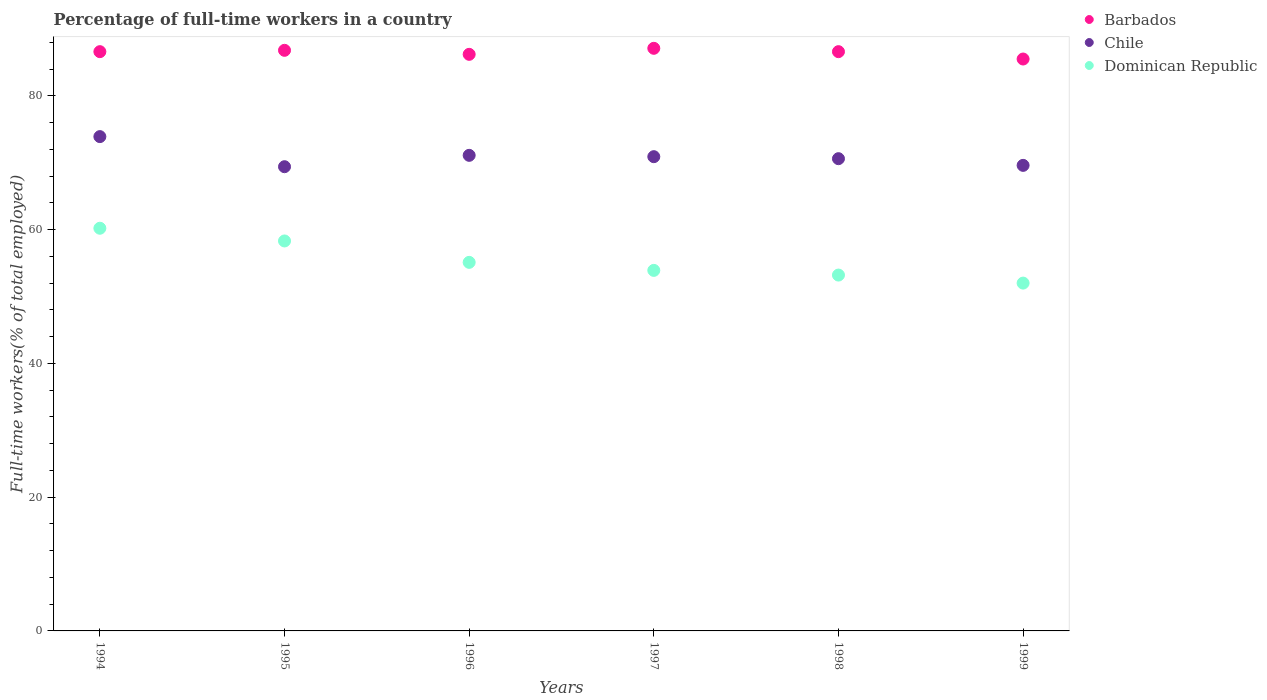Is the number of dotlines equal to the number of legend labels?
Give a very brief answer. Yes. What is the percentage of full-time workers in Barbados in 1995?
Your answer should be very brief. 86.8. Across all years, what is the maximum percentage of full-time workers in Chile?
Give a very brief answer. 73.9. Across all years, what is the minimum percentage of full-time workers in Dominican Republic?
Ensure brevity in your answer.  52. What is the total percentage of full-time workers in Dominican Republic in the graph?
Provide a succinct answer. 332.7. What is the difference between the percentage of full-time workers in Barbados in 1996 and that in 1998?
Your response must be concise. -0.4. What is the difference between the percentage of full-time workers in Barbados in 1998 and the percentage of full-time workers in Dominican Republic in 1996?
Your response must be concise. 31.5. What is the average percentage of full-time workers in Barbados per year?
Your answer should be compact. 86.47. In the year 1996, what is the difference between the percentage of full-time workers in Dominican Republic and percentage of full-time workers in Barbados?
Keep it short and to the point. -31.1. What is the ratio of the percentage of full-time workers in Dominican Republic in 1995 to that in 1998?
Your response must be concise. 1.1. What is the difference between the highest and the second highest percentage of full-time workers in Chile?
Ensure brevity in your answer.  2.8. What is the difference between the highest and the lowest percentage of full-time workers in Dominican Republic?
Keep it short and to the point. 8.2. Is the sum of the percentage of full-time workers in Chile in 1995 and 1997 greater than the maximum percentage of full-time workers in Barbados across all years?
Your response must be concise. Yes. Is it the case that in every year, the sum of the percentage of full-time workers in Dominican Republic and percentage of full-time workers in Chile  is greater than the percentage of full-time workers in Barbados?
Offer a terse response. Yes. Is the percentage of full-time workers in Chile strictly less than the percentage of full-time workers in Barbados over the years?
Provide a short and direct response. Yes. How many dotlines are there?
Ensure brevity in your answer.  3. How many years are there in the graph?
Give a very brief answer. 6. What is the difference between two consecutive major ticks on the Y-axis?
Your answer should be very brief. 20. Does the graph contain grids?
Provide a succinct answer. No. What is the title of the graph?
Your response must be concise. Percentage of full-time workers in a country. What is the label or title of the Y-axis?
Offer a terse response. Full-time workers(% of total employed). What is the Full-time workers(% of total employed) in Barbados in 1994?
Offer a terse response. 86.6. What is the Full-time workers(% of total employed) in Chile in 1994?
Your response must be concise. 73.9. What is the Full-time workers(% of total employed) in Dominican Republic in 1994?
Provide a succinct answer. 60.2. What is the Full-time workers(% of total employed) of Barbados in 1995?
Your answer should be compact. 86.8. What is the Full-time workers(% of total employed) of Chile in 1995?
Provide a succinct answer. 69.4. What is the Full-time workers(% of total employed) in Dominican Republic in 1995?
Your response must be concise. 58.3. What is the Full-time workers(% of total employed) in Barbados in 1996?
Provide a succinct answer. 86.2. What is the Full-time workers(% of total employed) of Chile in 1996?
Your answer should be compact. 71.1. What is the Full-time workers(% of total employed) of Dominican Republic in 1996?
Ensure brevity in your answer.  55.1. What is the Full-time workers(% of total employed) in Barbados in 1997?
Provide a succinct answer. 87.1. What is the Full-time workers(% of total employed) in Chile in 1997?
Offer a terse response. 70.9. What is the Full-time workers(% of total employed) in Dominican Republic in 1997?
Provide a short and direct response. 53.9. What is the Full-time workers(% of total employed) in Barbados in 1998?
Your response must be concise. 86.6. What is the Full-time workers(% of total employed) of Chile in 1998?
Make the answer very short. 70.6. What is the Full-time workers(% of total employed) in Dominican Republic in 1998?
Offer a very short reply. 53.2. What is the Full-time workers(% of total employed) in Barbados in 1999?
Provide a short and direct response. 85.5. What is the Full-time workers(% of total employed) in Chile in 1999?
Provide a short and direct response. 69.6. Across all years, what is the maximum Full-time workers(% of total employed) of Barbados?
Offer a terse response. 87.1. Across all years, what is the maximum Full-time workers(% of total employed) of Chile?
Your answer should be compact. 73.9. Across all years, what is the maximum Full-time workers(% of total employed) in Dominican Republic?
Offer a terse response. 60.2. Across all years, what is the minimum Full-time workers(% of total employed) in Barbados?
Ensure brevity in your answer.  85.5. Across all years, what is the minimum Full-time workers(% of total employed) of Chile?
Make the answer very short. 69.4. Across all years, what is the minimum Full-time workers(% of total employed) of Dominican Republic?
Your answer should be very brief. 52. What is the total Full-time workers(% of total employed) in Barbados in the graph?
Provide a short and direct response. 518.8. What is the total Full-time workers(% of total employed) of Chile in the graph?
Offer a very short reply. 425.5. What is the total Full-time workers(% of total employed) in Dominican Republic in the graph?
Make the answer very short. 332.7. What is the difference between the Full-time workers(% of total employed) of Barbados in 1994 and that in 1995?
Keep it short and to the point. -0.2. What is the difference between the Full-time workers(% of total employed) of Chile in 1994 and that in 1995?
Your response must be concise. 4.5. What is the difference between the Full-time workers(% of total employed) of Dominican Republic in 1994 and that in 1996?
Offer a terse response. 5.1. What is the difference between the Full-time workers(% of total employed) of Dominican Republic in 1994 and that in 1997?
Your response must be concise. 6.3. What is the difference between the Full-time workers(% of total employed) of Chile in 1994 and that in 1998?
Ensure brevity in your answer.  3.3. What is the difference between the Full-time workers(% of total employed) in Dominican Republic in 1994 and that in 1998?
Give a very brief answer. 7. What is the difference between the Full-time workers(% of total employed) of Dominican Republic in 1995 and that in 1996?
Make the answer very short. 3.2. What is the difference between the Full-time workers(% of total employed) of Chile in 1995 and that in 1997?
Ensure brevity in your answer.  -1.5. What is the difference between the Full-time workers(% of total employed) in Dominican Republic in 1995 and that in 1997?
Offer a very short reply. 4.4. What is the difference between the Full-time workers(% of total employed) of Chile in 1995 and that in 1998?
Make the answer very short. -1.2. What is the difference between the Full-time workers(% of total employed) in Dominican Republic in 1995 and that in 1998?
Provide a succinct answer. 5.1. What is the difference between the Full-time workers(% of total employed) in Chile in 1996 and that in 1997?
Your answer should be compact. 0.2. What is the difference between the Full-time workers(% of total employed) of Barbados in 1996 and that in 1998?
Offer a very short reply. -0.4. What is the difference between the Full-time workers(% of total employed) of Chile in 1996 and that in 1998?
Ensure brevity in your answer.  0.5. What is the difference between the Full-time workers(% of total employed) of Barbados in 1996 and that in 1999?
Ensure brevity in your answer.  0.7. What is the difference between the Full-time workers(% of total employed) in Chile in 1997 and that in 1998?
Keep it short and to the point. 0.3. What is the difference between the Full-time workers(% of total employed) in Dominican Republic in 1997 and that in 1998?
Offer a terse response. 0.7. What is the difference between the Full-time workers(% of total employed) of Chile in 1997 and that in 1999?
Offer a terse response. 1.3. What is the difference between the Full-time workers(% of total employed) of Chile in 1998 and that in 1999?
Offer a very short reply. 1. What is the difference between the Full-time workers(% of total employed) in Barbados in 1994 and the Full-time workers(% of total employed) in Chile in 1995?
Your answer should be very brief. 17.2. What is the difference between the Full-time workers(% of total employed) in Barbados in 1994 and the Full-time workers(% of total employed) in Dominican Republic in 1995?
Your answer should be very brief. 28.3. What is the difference between the Full-time workers(% of total employed) in Chile in 1994 and the Full-time workers(% of total employed) in Dominican Republic in 1995?
Ensure brevity in your answer.  15.6. What is the difference between the Full-time workers(% of total employed) in Barbados in 1994 and the Full-time workers(% of total employed) in Dominican Republic in 1996?
Give a very brief answer. 31.5. What is the difference between the Full-time workers(% of total employed) in Barbados in 1994 and the Full-time workers(% of total employed) in Dominican Republic in 1997?
Make the answer very short. 32.7. What is the difference between the Full-time workers(% of total employed) in Chile in 1994 and the Full-time workers(% of total employed) in Dominican Republic in 1997?
Provide a succinct answer. 20. What is the difference between the Full-time workers(% of total employed) of Barbados in 1994 and the Full-time workers(% of total employed) of Dominican Republic in 1998?
Offer a terse response. 33.4. What is the difference between the Full-time workers(% of total employed) in Chile in 1994 and the Full-time workers(% of total employed) in Dominican Republic in 1998?
Your response must be concise. 20.7. What is the difference between the Full-time workers(% of total employed) of Barbados in 1994 and the Full-time workers(% of total employed) of Chile in 1999?
Offer a very short reply. 17. What is the difference between the Full-time workers(% of total employed) of Barbados in 1994 and the Full-time workers(% of total employed) of Dominican Republic in 1999?
Offer a very short reply. 34.6. What is the difference between the Full-time workers(% of total employed) in Chile in 1994 and the Full-time workers(% of total employed) in Dominican Republic in 1999?
Keep it short and to the point. 21.9. What is the difference between the Full-time workers(% of total employed) in Barbados in 1995 and the Full-time workers(% of total employed) in Chile in 1996?
Your answer should be very brief. 15.7. What is the difference between the Full-time workers(% of total employed) in Barbados in 1995 and the Full-time workers(% of total employed) in Dominican Republic in 1996?
Your answer should be very brief. 31.7. What is the difference between the Full-time workers(% of total employed) of Chile in 1995 and the Full-time workers(% of total employed) of Dominican Republic in 1996?
Provide a succinct answer. 14.3. What is the difference between the Full-time workers(% of total employed) of Barbados in 1995 and the Full-time workers(% of total employed) of Dominican Republic in 1997?
Give a very brief answer. 32.9. What is the difference between the Full-time workers(% of total employed) in Barbados in 1995 and the Full-time workers(% of total employed) in Chile in 1998?
Keep it short and to the point. 16.2. What is the difference between the Full-time workers(% of total employed) in Barbados in 1995 and the Full-time workers(% of total employed) in Dominican Republic in 1998?
Offer a very short reply. 33.6. What is the difference between the Full-time workers(% of total employed) of Chile in 1995 and the Full-time workers(% of total employed) of Dominican Republic in 1998?
Your answer should be very brief. 16.2. What is the difference between the Full-time workers(% of total employed) of Barbados in 1995 and the Full-time workers(% of total employed) of Chile in 1999?
Your answer should be compact. 17.2. What is the difference between the Full-time workers(% of total employed) in Barbados in 1995 and the Full-time workers(% of total employed) in Dominican Republic in 1999?
Keep it short and to the point. 34.8. What is the difference between the Full-time workers(% of total employed) of Chile in 1995 and the Full-time workers(% of total employed) of Dominican Republic in 1999?
Your response must be concise. 17.4. What is the difference between the Full-time workers(% of total employed) in Barbados in 1996 and the Full-time workers(% of total employed) in Chile in 1997?
Keep it short and to the point. 15.3. What is the difference between the Full-time workers(% of total employed) of Barbados in 1996 and the Full-time workers(% of total employed) of Dominican Republic in 1997?
Your response must be concise. 32.3. What is the difference between the Full-time workers(% of total employed) of Barbados in 1996 and the Full-time workers(% of total employed) of Chile in 1998?
Offer a terse response. 15.6. What is the difference between the Full-time workers(% of total employed) of Barbados in 1996 and the Full-time workers(% of total employed) of Dominican Republic in 1998?
Offer a very short reply. 33. What is the difference between the Full-time workers(% of total employed) in Chile in 1996 and the Full-time workers(% of total employed) in Dominican Republic in 1998?
Provide a short and direct response. 17.9. What is the difference between the Full-time workers(% of total employed) in Barbados in 1996 and the Full-time workers(% of total employed) in Chile in 1999?
Your answer should be very brief. 16.6. What is the difference between the Full-time workers(% of total employed) of Barbados in 1996 and the Full-time workers(% of total employed) of Dominican Republic in 1999?
Your response must be concise. 34.2. What is the difference between the Full-time workers(% of total employed) in Barbados in 1997 and the Full-time workers(% of total employed) in Dominican Republic in 1998?
Make the answer very short. 33.9. What is the difference between the Full-time workers(% of total employed) in Barbados in 1997 and the Full-time workers(% of total employed) in Chile in 1999?
Provide a short and direct response. 17.5. What is the difference between the Full-time workers(% of total employed) in Barbados in 1997 and the Full-time workers(% of total employed) in Dominican Republic in 1999?
Your response must be concise. 35.1. What is the difference between the Full-time workers(% of total employed) in Chile in 1997 and the Full-time workers(% of total employed) in Dominican Republic in 1999?
Offer a terse response. 18.9. What is the difference between the Full-time workers(% of total employed) of Barbados in 1998 and the Full-time workers(% of total employed) of Chile in 1999?
Your answer should be very brief. 17. What is the difference between the Full-time workers(% of total employed) of Barbados in 1998 and the Full-time workers(% of total employed) of Dominican Republic in 1999?
Offer a terse response. 34.6. What is the average Full-time workers(% of total employed) of Barbados per year?
Offer a terse response. 86.47. What is the average Full-time workers(% of total employed) in Chile per year?
Your response must be concise. 70.92. What is the average Full-time workers(% of total employed) in Dominican Republic per year?
Give a very brief answer. 55.45. In the year 1994, what is the difference between the Full-time workers(% of total employed) in Barbados and Full-time workers(% of total employed) in Dominican Republic?
Your answer should be compact. 26.4. In the year 1995, what is the difference between the Full-time workers(% of total employed) of Barbados and Full-time workers(% of total employed) of Chile?
Provide a short and direct response. 17.4. In the year 1995, what is the difference between the Full-time workers(% of total employed) in Chile and Full-time workers(% of total employed) in Dominican Republic?
Give a very brief answer. 11.1. In the year 1996, what is the difference between the Full-time workers(% of total employed) of Barbados and Full-time workers(% of total employed) of Chile?
Provide a succinct answer. 15.1. In the year 1996, what is the difference between the Full-time workers(% of total employed) in Barbados and Full-time workers(% of total employed) in Dominican Republic?
Your response must be concise. 31.1. In the year 1996, what is the difference between the Full-time workers(% of total employed) of Chile and Full-time workers(% of total employed) of Dominican Republic?
Provide a succinct answer. 16. In the year 1997, what is the difference between the Full-time workers(% of total employed) of Barbados and Full-time workers(% of total employed) of Chile?
Give a very brief answer. 16.2. In the year 1997, what is the difference between the Full-time workers(% of total employed) of Barbados and Full-time workers(% of total employed) of Dominican Republic?
Give a very brief answer. 33.2. In the year 1998, what is the difference between the Full-time workers(% of total employed) of Barbados and Full-time workers(% of total employed) of Dominican Republic?
Make the answer very short. 33.4. In the year 1998, what is the difference between the Full-time workers(% of total employed) in Chile and Full-time workers(% of total employed) in Dominican Republic?
Offer a terse response. 17.4. In the year 1999, what is the difference between the Full-time workers(% of total employed) in Barbados and Full-time workers(% of total employed) in Chile?
Keep it short and to the point. 15.9. In the year 1999, what is the difference between the Full-time workers(% of total employed) in Barbados and Full-time workers(% of total employed) in Dominican Republic?
Offer a very short reply. 33.5. What is the ratio of the Full-time workers(% of total employed) in Barbados in 1994 to that in 1995?
Your answer should be compact. 1. What is the ratio of the Full-time workers(% of total employed) of Chile in 1994 to that in 1995?
Keep it short and to the point. 1.06. What is the ratio of the Full-time workers(% of total employed) in Dominican Republic in 1994 to that in 1995?
Give a very brief answer. 1.03. What is the ratio of the Full-time workers(% of total employed) of Chile in 1994 to that in 1996?
Make the answer very short. 1.04. What is the ratio of the Full-time workers(% of total employed) of Dominican Republic in 1994 to that in 1996?
Your response must be concise. 1.09. What is the ratio of the Full-time workers(% of total employed) of Chile in 1994 to that in 1997?
Provide a succinct answer. 1.04. What is the ratio of the Full-time workers(% of total employed) in Dominican Republic in 1994 to that in 1997?
Your answer should be very brief. 1.12. What is the ratio of the Full-time workers(% of total employed) of Barbados in 1994 to that in 1998?
Make the answer very short. 1. What is the ratio of the Full-time workers(% of total employed) in Chile in 1994 to that in 1998?
Ensure brevity in your answer.  1.05. What is the ratio of the Full-time workers(% of total employed) of Dominican Republic in 1994 to that in 1998?
Ensure brevity in your answer.  1.13. What is the ratio of the Full-time workers(% of total employed) in Barbados in 1994 to that in 1999?
Ensure brevity in your answer.  1.01. What is the ratio of the Full-time workers(% of total employed) in Chile in 1994 to that in 1999?
Make the answer very short. 1.06. What is the ratio of the Full-time workers(% of total employed) in Dominican Republic in 1994 to that in 1999?
Provide a succinct answer. 1.16. What is the ratio of the Full-time workers(% of total employed) of Chile in 1995 to that in 1996?
Give a very brief answer. 0.98. What is the ratio of the Full-time workers(% of total employed) of Dominican Republic in 1995 to that in 1996?
Provide a succinct answer. 1.06. What is the ratio of the Full-time workers(% of total employed) in Chile in 1995 to that in 1997?
Provide a succinct answer. 0.98. What is the ratio of the Full-time workers(% of total employed) of Dominican Republic in 1995 to that in 1997?
Provide a succinct answer. 1.08. What is the ratio of the Full-time workers(% of total employed) of Chile in 1995 to that in 1998?
Keep it short and to the point. 0.98. What is the ratio of the Full-time workers(% of total employed) in Dominican Republic in 1995 to that in 1998?
Your response must be concise. 1.1. What is the ratio of the Full-time workers(% of total employed) of Barbados in 1995 to that in 1999?
Offer a very short reply. 1.02. What is the ratio of the Full-time workers(% of total employed) in Chile in 1995 to that in 1999?
Provide a succinct answer. 1. What is the ratio of the Full-time workers(% of total employed) in Dominican Republic in 1995 to that in 1999?
Ensure brevity in your answer.  1.12. What is the ratio of the Full-time workers(% of total employed) of Barbados in 1996 to that in 1997?
Your answer should be compact. 0.99. What is the ratio of the Full-time workers(% of total employed) in Chile in 1996 to that in 1997?
Offer a terse response. 1. What is the ratio of the Full-time workers(% of total employed) of Dominican Republic in 1996 to that in 1997?
Ensure brevity in your answer.  1.02. What is the ratio of the Full-time workers(% of total employed) of Barbados in 1996 to that in 1998?
Your response must be concise. 1. What is the ratio of the Full-time workers(% of total employed) of Chile in 1996 to that in 1998?
Give a very brief answer. 1.01. What is the ratio of the Full-time workers(% of total employed) of Dominican Republic in 1996 to that in 1998?
Provide a short and direct response. 1.04. What is the ratio of the Full-time workers(% of total employed) in Barbados in 1996 to that in 1999?
Your answer should be compact. 1.01. What is the ratio of the Full-time workers(% of total employed) in Chile in 1996 to that in 1999?
Offer a terse response. 1.02. What is the ratio of the Full-time workers(% of total employed) of Dominican Republic in 1996 to that in 1999?
Ensure brevity in your answer.  1.06. What is the ratio of the Full-time workers(% of total employed) in Dominican Republic in 1997 to that in 1998?
Provide a short and direct response. 1.01. What is the ratio of the Full-time workers(% of total employed) in Barbados in 1997 to that in 1999?
Offer a very short reply. 1.02. What is the ratio of the Full-time workers(% of total employed) of Chile in 1997 to that in 1999?
Your response must be concise. 1.02. What is the ratio of the Full-time workers(% of total employed) in Dominican Republic in 1997 to that in 1999?
Your answer should be compact. 1.04. What is the ratio of the Full-time workers(% of total employed) of Barbados in 1998 to that in 1999?
Provide a short and direct response. 1.01. What is the ratio of the Full-time workers(% of total employed) in Chile in 1998 to that in 1999?
Provide a short and direct response. 1.01. What is the ratio of the Full-time workers(% of total employed) in Dominican Republic in 1998 to that in 1999?
Make the answer very short. 1.02. What is the difference between the highest and the second highest Full-time workers(% of total employed) of Barbados?
Give a very brief answer. 0.3. What is the difference between the highest and the second highest Full-time workers(% of total employed) in Chile?
Provide a succinct answer. 2.8. What is the difference between the highest and the second highest Full-time workers(% of total employed) in Dominican Republic?
Give a very brief answer. 1.9. What is the difference between the highest and the lowest Full-time workers(% of total employed) in Dominican Republic?
Keep it short and to the point. 8.2. 